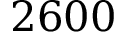Convert formula to latex. <formula><loc_0><loc_0><loc_500><loc_500>2 6 0 0</formula> 